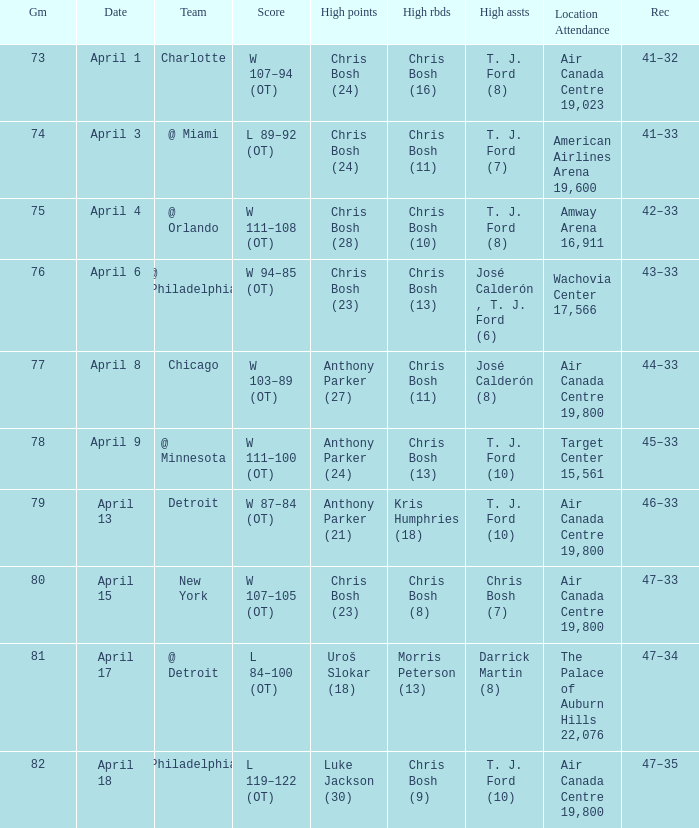Would you be able to parse every entry in this table? {'header': ['Gm', 'Date', 'Team', 'Score', 'High points', 'High rbds', 'High assts', 'Location Attendance', 'Rec'], 'rows': [['73', 'April 1', 'Charlotte', 'W 107–94 (OT)', 'Chris Bosh (24)', 'Chris Bosh (16)', 'T. J. Ford (8)', 'Air Canada Centre 19,023', '41–32'], ['74', 'April 3', '@ Miami', 'L 89–92 (OT)', 'Chris Bosh (24)', 'Chris Bosh (11)', 'T. J. Ford (7)', 'American Airlines Arena 19,600', '41–33'], ['75', 'April 4', '@ Orlando', 'W 111–108 (OT)', 'Chris Bosh (28)', 'Chris Bosh (10)', 'T. J. Ford (8)', 'Amway Arena 16,911', '42–33'], ['76', 'April 6', '@ Philadelphia', 'W 94–85 (OT)', 'Chris Bosh (23)', 'Chris Bosh (13)', 'José Calderón , T. J. Ford (6)', 'Wachovia Center 17,566', '43–33'], ['77', 'April 8', 'Chicago', 'W 103–89 (OT)', 'Anthony Parker (27)', 'Chris Bosh (11)', 'José Calderón (8)', 'Air Canada Centre 19,800', '44–33'], ['78', 'April 9', '@ Minnesota', 'W 111–100 (OT)', 'Anthony Parker (24)', 'Chris Bosh (13)', 'T. J. Ford (10)', 'Target Center 15,561', '45–33'], ['79', 'April 13', 'Detroit', 'W 87–84 (OT)', 'Anthony Parker (21)', 'Kris Humphries (18)', 'T. J. Ford (10)', 'Air Canada Centre 19,800', '46–33'], ['80', 'April 15', 'New York', 'W 107–105 (OT)', 'Chris Bosh (23)', 'Chris Bosh (8)', 'Chris Bosh (7)', 'Air Canada Centre 19,800', '47–33'], ['81', 'April 17', '@ Detroit', 'L 84–100 (OT)', 'Uroš Slokar (18)', 'Morris Peterson (13)', 'Darrick Martin (8)', 'The Palace of Auburn Hills 22,076', '47–34'], ['82', 'April 18', 'Philadelphia', 'L 119–122 (OT)', 'Luke Jackson (30)', 'Chris Bosh (9)', 'T. J. Ford (10)', 'Air Canada Centre 19,800', '47–35']]} What was the score of game 82? L 119–122 (OT). 